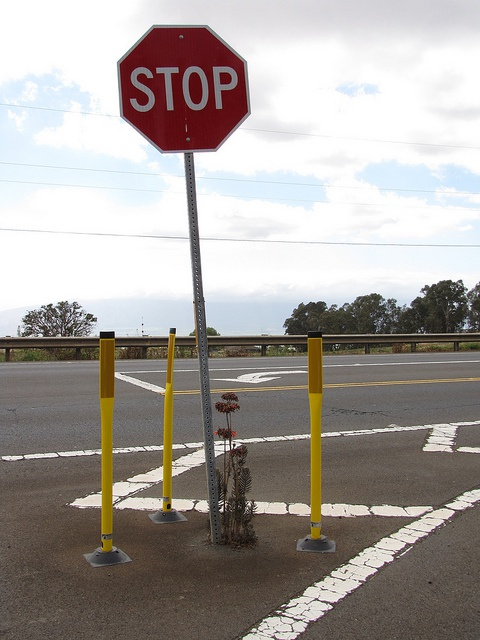Describe the objects in this image and their specific colors. I can see a stop sign in white, maroon, and gray tones in this image. 